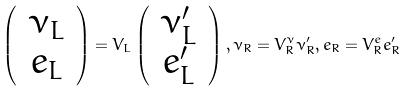<formula> <loc_0><loc_0><loc_500><loc_500>\left ( \, \begin{array} { c } \nu _ { L } \\ e _ { L } \end{array} \, \right ) = V _ { L } \left ( \, \begin{array} { c } \nu ^ { \prime } _ { L } \\ e ^ { \prime } _ { L } \end{array} \, \right ) , \nu _ { R } = V _ { R } ^ { \nu } \nu ^ { \prime } _ { R } , e _ { R } = V _ { R } ^ { e } e ^ { \prime } _ { R }</formula> 